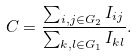Convert formula to latex. <formula><loc_0><loc_0><loc_500><loc_500>C = \frac { \sum _ { i , j \in G _ { 2 } } I _ { i j } } { \sum _ { k , l \in G _ { 1 } } I _ { k l } } .</formula> 